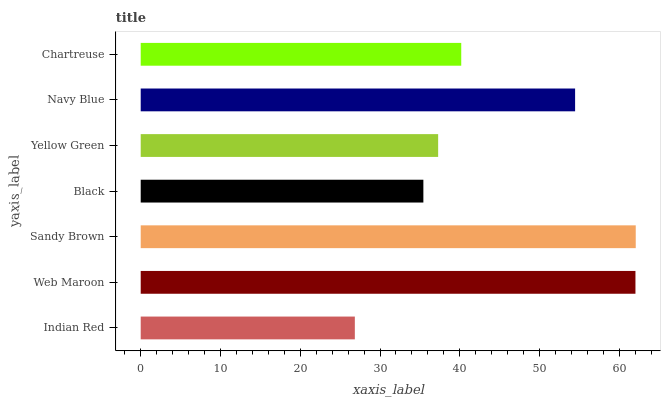Is Indian Red the minimum?
Answer yes or no. Yes. Is Sandy Brown the maximum?
Answer yes or no. Yes. Is Web Maroon the minimum?
Answer yes or no. No. Is Web Maroon the maximum?
Answer yes or no. No. Is Web Maroon greater than Indian Red?
Answer yes or no. Yes. Is Indian Red less than Web Maroon?
Answer yes or no. Yes. Is Indian Red greater than Web Maroon?
Answer yes or no. No. Is Web Maroon less than Indian Red?
Answer yes or no. No. Is Chartreuse the high median?
Answer yes or no. Yes. Is Chartreuse the low median?
Answer yes or no. Yes. Is Black the high median?
Answer yes or no. No. Is Web Maroon the low median?
Answer yes or no. No. 